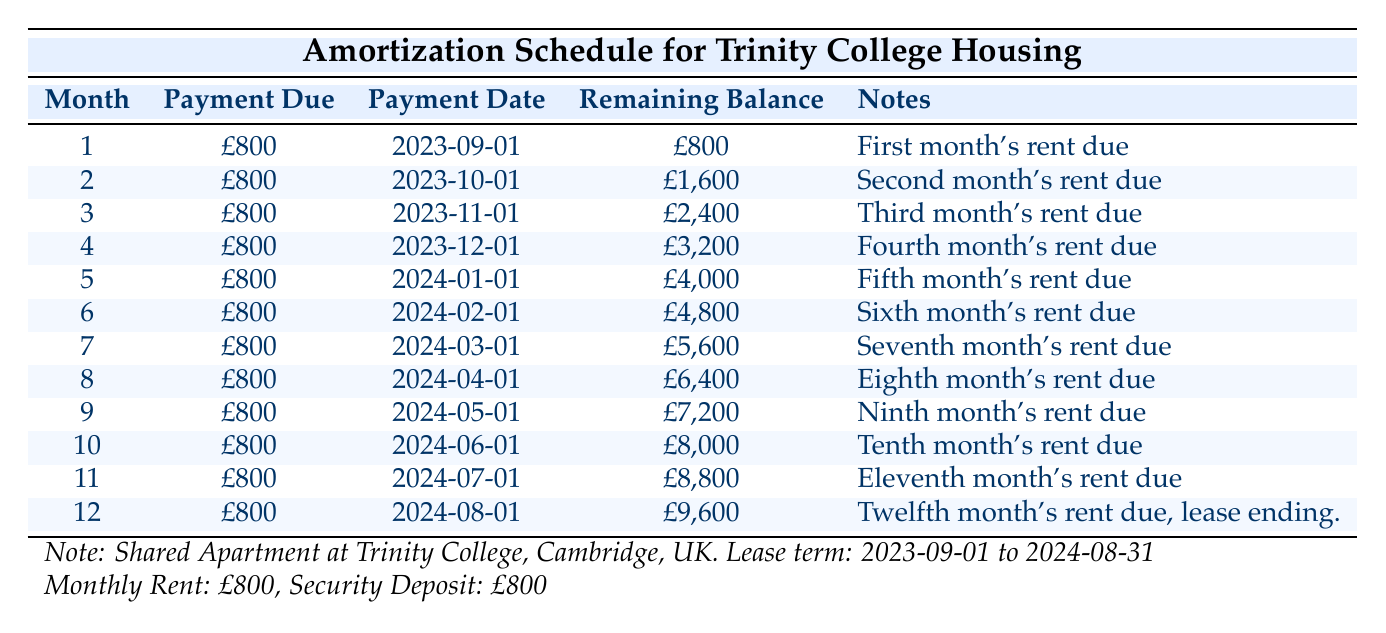What is the monthly rent for the shared apartment at Trinity College? The table clearly states that the monthly rent is £800. This information is straightforwardly listed under "Monthly Rent."
Answer: £800 How many months does the lease term cover? The lease term begins on 2023-09-01 and ends on 2024-08-31, which is a total of 12 months. This can be confirmed by counting the months from September 2023 to August 2024.
Answer: 12 months What is the remaining balance after the second month? According to the table, after the second month's payment due on 2023-10-01, the remaining balance is £1,600. This is directly mentioned under the "Remaining Balance" column.
Answer: £1,600 Is the payment due for the first month different from the others? The table indicates that the payment due for the first month is £800, which is the same as for all other months; thus, the statement is false.
Answer: No What is the total remaining balance after six months? To find the total remaining balance after six months, we look at the "Remaining Balance" for month 6, which is £4,800. This number is explicitly stated in the table for that particular month.
Answer: £4,800 How many payments are due in total during the lease? The lease covers 12 months, and since a payment is due each month, there are 12 payments in total. This can be verified by counting the months listed in the table.
Answer: 12 payments What is the average remaining balance after all payments are due? The remaining balances for each month are £800, £1,600, £2,400, £3,200, £4,000, £4,800, £5,600, £6,400, £7,200, £8,000, £8,800, and £9,600. To find the average, we calculate the sum of all balances (which is £57,600) and divide by the number of months (12), resulting in an average of £4,800.
Answer: £4,800 What is the purpose of the security deposit? The table indicates that a security deposit of £800 is required, typically to cover any damages or unpaid rent at the end of the lease.
Answer: Security deposit for damages/unpaid rent Was the last payment due on the same day the lease ends? The last payment due is on 2024-08-01, and the lease ends on 2024-08-31, indicating that the last payment is indeed made on the same month, but before the lease officially ends. Therefore, the statement is true.
Answer: Yes 